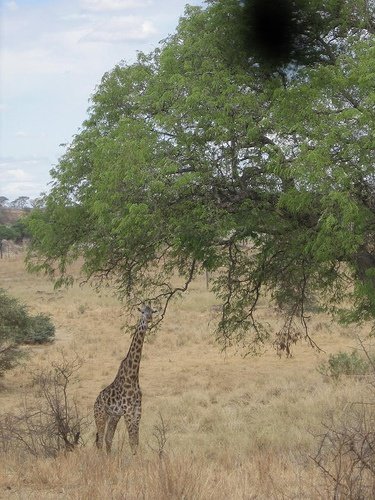Describe the objects in this image and their specific colors. I can see a giraffe in lightblue and gray tones in this image. 